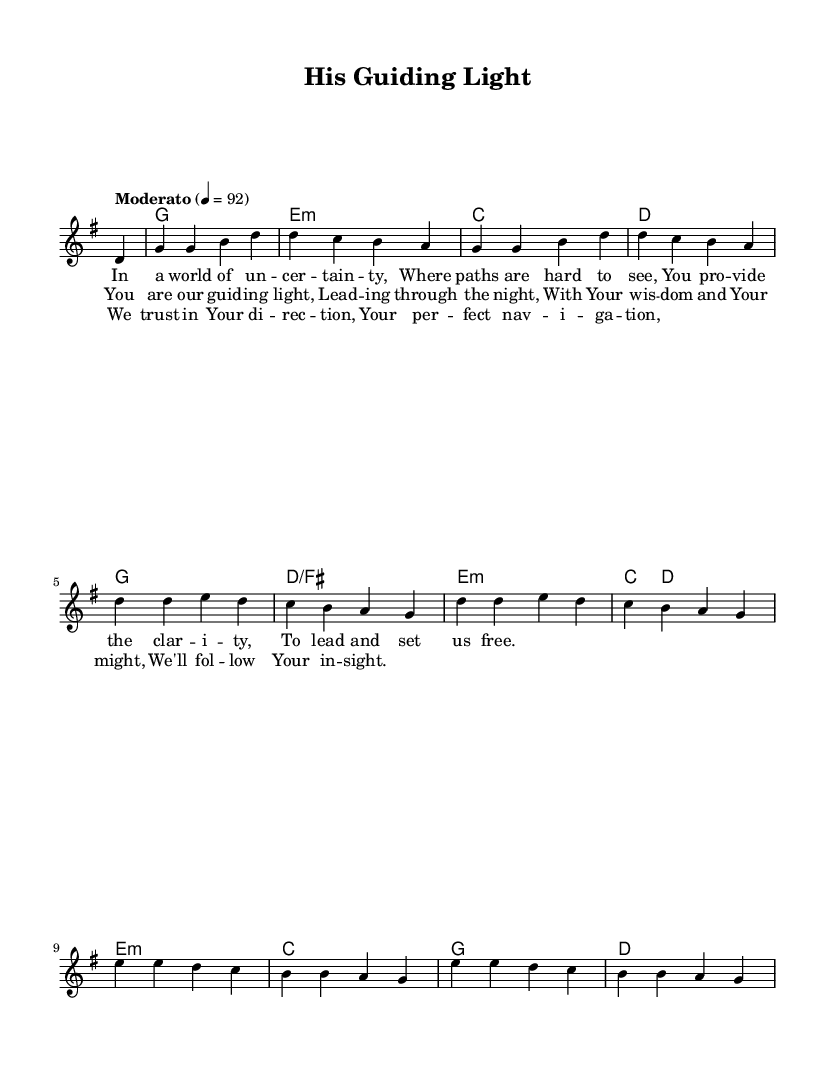What is the key signature of this music? The key signature is G major, which has one sharp (F#). This can be determined by looking at the key signature notation at the beginning of the score.
Answer: G major What is the time signature of the piece? The time signature is 4/4, indicated at the start of the score, which shows that there are four beats in each measure.
Answer: 4/4 What is the tempo marking for this piece? The tempo marking is "Moderato," which indicates a moderate speed. This is noted above the staff at the beginning of the piece.
Answer: Moderato How many measures are in the verse? The verse consists of four measures, as can be counted from the explicit notation of the melody and harmonies. Each line of the lyrics corresponds to one measure.
Answer: Four What is the primary theme conveyed in the lyrics? The primary theme is guidance and leadership from a higher power, as reflected in phrases like "guiding light" and "lead us free," showcasing the reliance on divine direction. This can be inferred from the entirety of the lyrics' content.
Answer: Guidance What chords are used in the chorus? The chords used in the chorus are G, E minor, C, and D. These chords can be identified by looking at the chord symbols written above the respective measures in the score.
Answer: G, E minor, C, D What does the bridge emphasize? The bridge emphasizes trust in divine direction and navigation, highlighting reliance on a higher power for guidance. This is evident in the lyrics specifically focusing on direction and navigation, indicating a shift in the piece's emotional tone.
Answer: Di-rection 